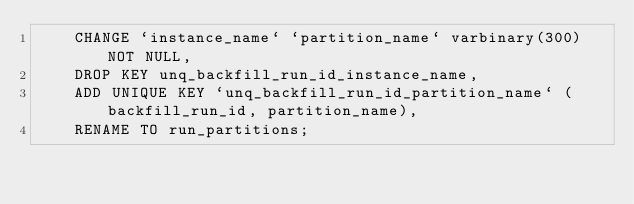<code> <loc_0><loc_0><loc_500><loc_500><_SQL_>    CHANGE `instance_name` `partition_name` varbinary(300) NOT NULL,
    DROP KEY unq_backfill_run_id_instance_name,
    ADD UNIQUE KEY `unq_backfill_run_id_partition_name` (backfill_run_id, partition_name),
    RENAME TO run_partitions;</code> 